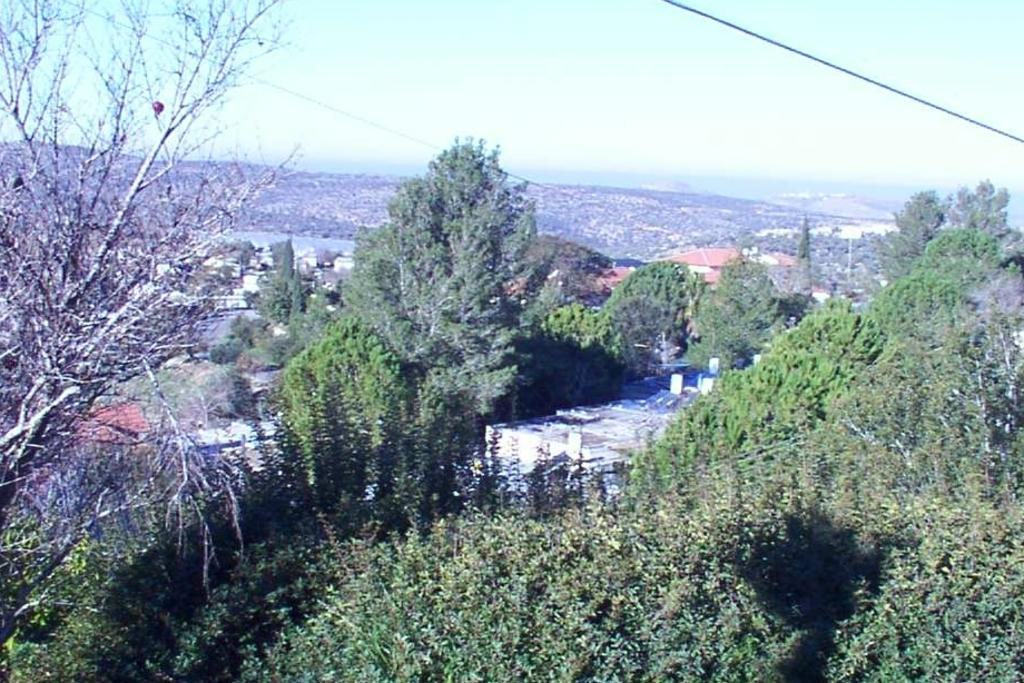What type of structures can be seen in the image? There are buildings in the image. What other natural elements are present in the image? There are trees in the image. What can be seen in the distance in the image? The sky is visible in the background of the image. What book is the person reading in the image? There is no person or book present in the image; it only features buildings, trees, and the sky. 